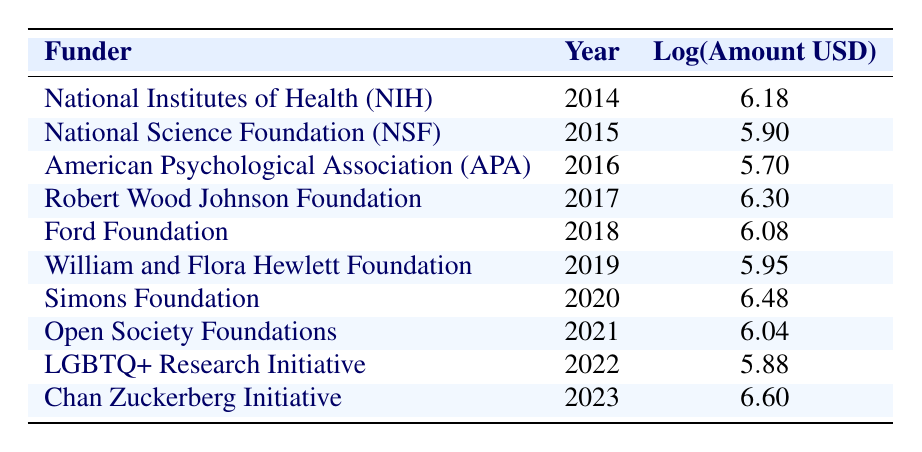What is the funding amount from the Simons Foundation in 2020? The table shows that the Simons Foundation provided a funding amount of 3,000,000 USD in the year 2020.
Answer: 3,000,000 Which year saw the highest logarithmic value of funding? By examining the "Log(Amount USD)" column in the table, the highest value is 6.60, which corresponds to the year 2023 under the Chan Zuckerberg Initiative.
Answer: 2023 What is the funding difference between the years 2014 and 2019? For 2014, the funding amount is 1,500,000 USD (log 6.18) and for 2019, it is 900,000 USD (log 5.95). The difference is 1,500,000 - 900,000 = 600,000 USD.
Answer: 600,000 Was there any funding from the American Psychological Association in 2021? The table shows that the American Psychological Association provided funding only in 2016, so there was no funding from them in 2021.
Answer: No What is the average log funding amount over the decade from 2014 to 2023? To find the average, sum the logarithmic values: 6.18 + 5.90 + 5.70 + 6.30 + 6.08 + 5.95 + 6.48 + 6.04 + 5.88 + 6.60 = 60.11. There are 10 years, so the average is 60.11 / 10 = 6.01.
Answer: 6.01 How many funders contributed more than 1,000,000 USD in the decade? Looking through the funding amounts, the funders that provided more than 1,000,000 USD are NIH (2014), Robert Wood Johnson Foundation (2017), Simons Foundation (2020), and Chan Zuckerberg Initiative (2023), totaling four funders.
Answer: 4 Which funder contributed the least in the year 2022? The table shows the funding amount for the LGBTQ+ Research Initiative in 2022 is 750,000 USD, and it is the only entry for that year, making it the least.
Answer: LGBTQ+ Research Initiative What was the total funding amount from all sources in 2018 and 2019? The funding amounts in 2018 (1,200,000 USD) and 2019 (900,000 USD) are summed up: 1,200,000 + 900,000 = 2,100,000 USD total.
Answer: 2,100,000 